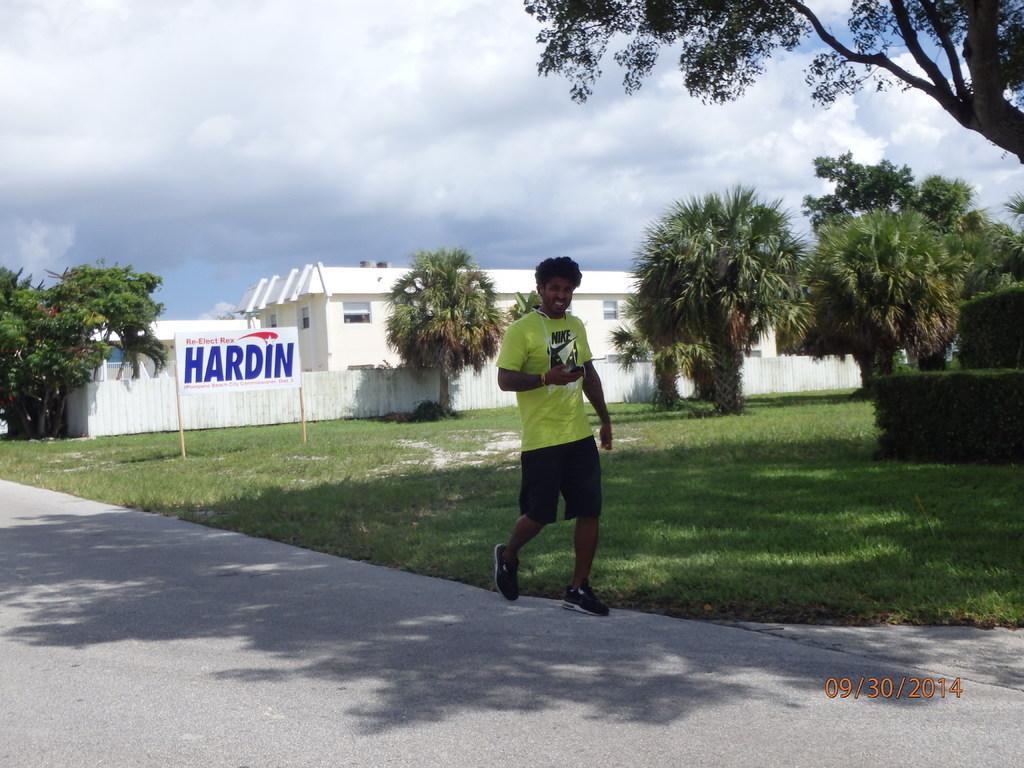In one or two sentences, can you explain what this image depicts? In this image I can see a person walking on the road. I can see a building, a board with some text and trees behind him. I can see the garden with grass in the center of the image. At the top of the image I can see the sky. In the right bottom corner, I can see the date. 